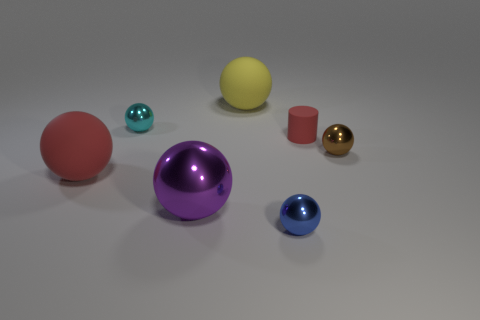Subtract all tiny cyan metallic spheres. How many spheres are left? 5 Subtract all cyan balls. How many balls are left? 5 Add 1 red objects. How many objects exist? 8 Subtract 1 cylinders. How many cylinders are left? 0 Subtract all cylinders. How many objects are left? 6 Add 1 brown balls. How many brown balls are left? 2 Add 4 big spheres. How many big spheres exist? 7 Subtract 1 cyan spheres. How many objects are left? 6 Subtract all red spheres. Subtract all blue cubes. How many spheres are left? 5 Subtract all cyan cylinders. How many red spheres are left? 1 